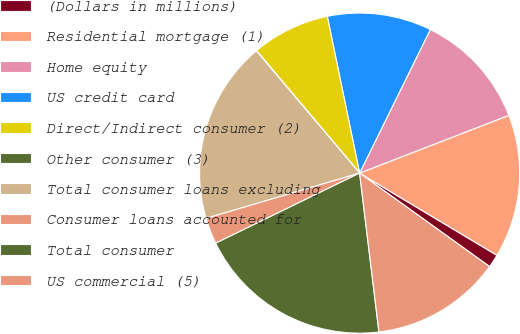Convert chart to OTSL. <chart><loc_0><loc_0><loc_500><loc_500><pie_chart><fcel>(Dollars in millions)<fcel>Residential mortgage (1)<fcel>Home equity<fcel>US credit card<fcel>Direct/Indirect consumer (2)<fcel>Other consumer (3)<fcel>Total consumer loans excluding<fcel>Consumer loans accounted for<fcel>Total consumer<fcel>US commercial (5)<nl><fcel>1.34%<fcel>14.46%<fcel>11.84%<fcel>10.52%<fcel>7.9%<fcel>0.03%<fcel>18.4%<fcel>2.65%<fcel>19.71%<fcel>13.15%<nl></chart> 